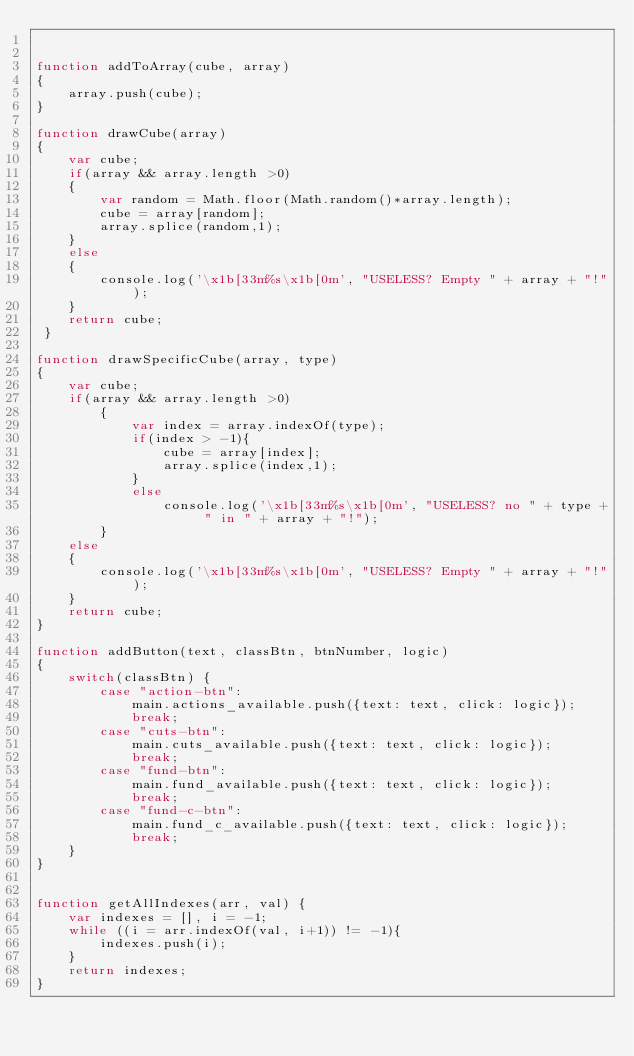<code> <loc_0><loc_0><loc_500><loc_500><_JavaScript_>

function addToArray(cube, array) 
{
    array.push(cube);
} 

function drawCube(array) 
{
    var cube;
    if(array && array.length >0)
    {
        var random = Math.floor(Math.random()*array.length);
        cube = array[random];
        array.splice(random,1);
    }
    else
    {
        console.log('\x1b[33m%s\x1b[0m', "USELESS? Empty " + array + "!");
    } 
    return cube;
 } 

function drawSpecificCube(array, type)
{
    var cube;
    if(array && array.length >0)
        {
            var index = array.indexOf(type);
            if(index > -1){
                cube = array[index];
                array.splice(index,1);
            }
            else
                console.log('\x1b[33m%s\x1b[0m', "USELESS? no " + type + " in " + array + "!");
        }
    else
    {
        console.log('\x1b[33m%s\x1b[0m', "USELESS? Empty " + array + "!");
    } 
    return cube;    
} 

function addButton(text, classBtn, btnNumber, logic)
{
    switch(classBtn) {
        case "action-btn": 
            main.actions_available.push({text: text, click: logic});
            break;
        case "cuts-btn": 
            main.cuts_available.push({text: text, click: logic});
            break;
        case "fund-btn": 
            main.fund_available.push({text: text, click: logic});
            break;
        case "fund-c-btn": 
            main.fund_c_available.push({text: text, click: logic});
            break;
    }
}


function getAllIndexes(arr, val) {
    var indexes = [], i = -1;
    while ((i = arr.indexOf(val, i+1)) != -1){
        indexes.push(i);
    }
    return indexes;
}


</code> 